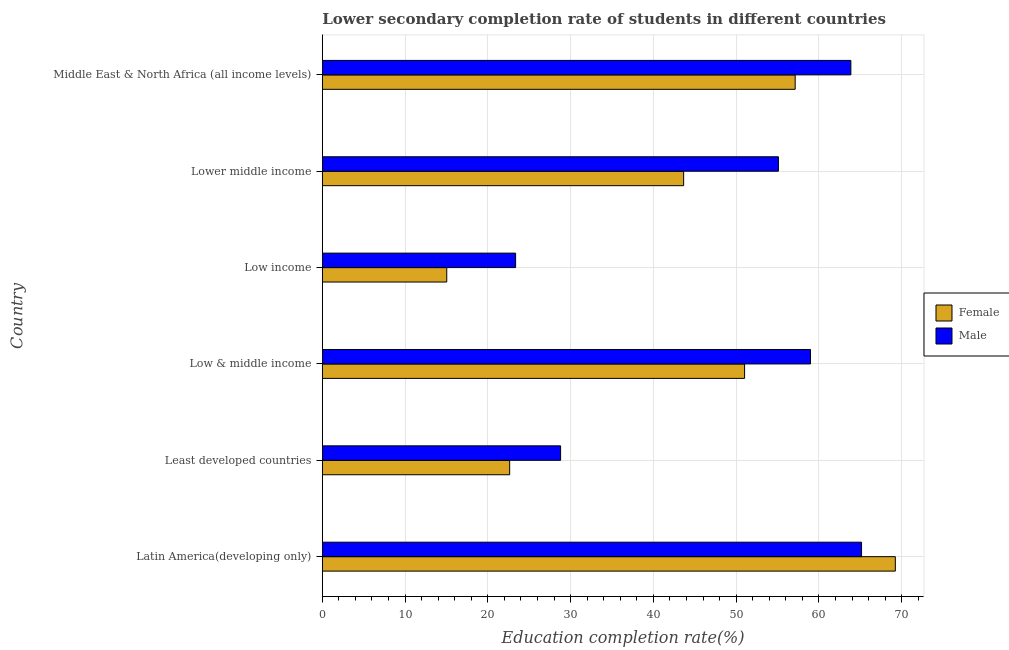How many different coloured bars are there?
Your response must be concise. 2. Are the number of bars per tick equal to the number of legend labels?
Make the answer very short. Yes. How many bars are there on the 1st tick from the bottom?
Make the answer very short. 2. What is the label of the 1st group of bars from the top?
Keep it short and to the point. Middle East & North Africa (all income levels). In how many cases, is the number of bars for a given country not equal to the number of legend labels?
Give a very brief answer. 0. What is the education completion rate of female students in Latin America(developing only)?
Keep it short and to the point. 69.23. Across all countries, what is the maximum education completion rate of female students?
Your answer should be compact. 69.23. Across all countries, what is the minimum education completion rate of female students?
Provide a short and direct response. 15.03. In which country was the education completion rate of female students maximum?
Keep it short and to the point. Latin America(developing only). In which country was the education completion rate of female students minimum?
Make the answer very short. Low income. What is the total education completion rate of female students in the graph?
Make the answer very short. 258.71. What is the difference between the education completion rate of male students in Least developed countries and that in Low income?
Make the answer very short. 5.43. What is the difference between the education completion rate of female students in Latin America(developing only) and the education completion rate of male students in Lower middle income?
Ensure brevity in your answer.  14.13. What is the average education completion rate of male students per country?
Your answer should be very brief. 49.21. What is the difference between the education completion rate of male students and education completion rate of female students in Low & middle income?
Make the answer very short. 7.97. What is the ratio of the education completion rate of female students in Least developed countries to that in Low & middle income?
Provide a succinct answer. 0.44. Is the education completion rate of male students in Latin America(developing only) less than that in Least developed countries?
Offer a very short reply. No. What is the difference between the highest and the second highest education completion rate of female students?
Offer a very short reply. 12.1. What is the difference between the highest and the lowest education completion rate of female students?
Your response must be concise. 54.2. What does the 2nd bar from the top in Middle East & North Africa (all income levels) represents?
Your response must be concise. Female. What does the 1st bar from the bottom in Lower middle income represents?
Ensure brevity in your answer.  Female. How many bars are there?
Your response must be concise. 12. How many countries are there in the graph?
Provide a succinct answer. 6. What is the difference between two consecutive major ticks on the X-axis?
Your response must be concise. 10. Does the graph contain any zero values?
Provide a succinct answer. No. Where does the legend appear in the graph?
Make the answer very short. Center right. How are the legend labels stacked?
Your answer should be compact. Vertical. What is the title of the graph?
Ensure brevity in your answer.  Lower secondary completion rate of students in different countries. What is the label or title of the X-axis?
Give a very brief answer. Education completion rate(%). What is the label or title of the Y-axis?
Provide a succinct answer. Country. What is the Education completion rate(%) of Female in Latin America(developing only)?
Give a very brief answer. 69.23. What is the Education completion rate(%) in Male in Latin America(developing only)?
Your answer should be compact. 65.15. What is the Education completion rate(%) of Female in Least developed countries?
Ensure brevity in your answer.  22.63. What is the Education completion rate(%) in Male in Least developed countries?
Ensure brevity in your answer.  28.79. What is the Education completion rate(%) in Female in Low & middle income?
Provide a succinct answer. 51.02. What is the Education completion rate(%) of Male in Low & middle income?
Give a very brief answer. 58.98. What is the Education completion rate(%) of Female in Low income?
Keep it short and to the point. 15.03. What is the Education completion rate(%) of Male in Low income?
Offer a very short reply. 23.35. What is the Education completion rate(%) of Female in Lower middle income?
Give a very brief answer. 43.66. What is the Education completion rate(%) of Male in Lower middle income?
Your answer should be very brief. 55.11. What is the Education completion rate(%) of Female in Middle East & North Africa (all income levels)?
Your answer should be compact. 57.13. What is the Education completion rate(%) of Male in Middle East & North Africa (all income levels)?
Make the answer very short. 63.86. Across all countries, what is the maximum Education completion rate(%) in Female?
Your response must be concise. 69.23. Across all countries, what is the maximum Education completion rate(%) of Male?
Offer a very short reply. 65.15. Across all countries, what is the minimum Education completion rate(%) in Female?
Keep it short and to the point. 15.03. Across all countries, what is the minimum Education completion rate(%) of Male?
Offer a terse response. 23.35. What is the total Education completion rate(%) in Female in the graph?
Your answer should be very brief. 258.71. What is the total Education completion rate(%) in Male in the graph?
Provide a short and direct response. 295.24. What is the difference between the Education completion rate(%) of Female in Latin America(developing only) and that in Least developed countries?
Offer a very short reply. 46.6. What is the difference between the Education completion rate(%) of Male in Latin America(developing only) and that in Least developed countries?
Provide a succinct answer. 36.36. What is the difference between the Education completion rate(%) of Female in Latin America(developing only) and that in Low & middle income?
Keep it short and to the point. 18.21. What is the difference between the Education completion rate(%) in Male in Latin America(developing only) and that in Low & middle income?
Keep it short and to the point. 6.17. What is the difference between the Education completion rate(%) in Female in Latin America(developing only) and that in Low income?
Make the answer very short. 54.2. What is the difference between the Education completion rate(%) of Male in Latin America(developing only) and that in Low income?
Provide a short and direct response. 41.8. What is the difference between the Education completion rate(%) in Female in Latin America(developing only) and that in Lower middle income?
Ensure brevity in your answer.  25.58. What is the difference between the Education completion rate(%) of Male in Latin America(developing only) and that in Lower middle income?
Provide a short and direct response. 10.04. What is the difference between the Education completion rate(%) in Female in Latin America(developing only) and that in Middle East & North Africa (all income levels)?
Keep it short and to the point. 12.1. What is the difference between the Education completion rate(%) in Male in Latin America(developing only) and that in Middle East & North Africa (all income levels)?
Give a very brief answer. 1.29. What is the difference between the Education completion rate(%) of Female in Least developed countries and that in Low & middle income?
Make the answer very short. -28.38. What is the difference between the Education completion rate(%) of Male in Least developed countries and that in Low & middle income?
Ensure brevity in your answer.  -30.19. What is the difference between the Education completion rate(%) of Female in Least developed countries and that in Low income?
Give a very brief answer. 7.6. What is the difference between the Education completion rate(%) of Male in Least developed countries and that in Low income?
Provide a short and direct response. 5.44. What is the difference between the Education completion rate(%) in Female in Least developed countries and that in Lower middle income?
Provide a succinct answer. -21.02. What is the difference between the Education completion rate(%) of Male in Least developed countries and that in Lower middle income?
Ensure brevity in your answer.  -26.32. What is the difference between the Education completion rate(%) in Female in Least developed countries and that in Middle East & North Africa (all income levels)?
Make the answer very short. -34.5. What is the difference between the Education completion rate(%) of Male in Least developed countries and that in Middle East & North Africa (all income levels)?
Offer a terse response. -35.07. What is the difference between the Education completion rate(%) in Female in Low & middle income and that in Low income?
Give a very brief answer. 35.99. What is the difference between the Education completion rate(%) of Male in Low & middle income and that in Low income?
Your answer should be compact. 35.63. What is the difference between the Education completion rate(%) in Female in Low & middle income and that in Lower middle income?
Keep it short and to the point. 7.36. What is the difference between the Education completion rate(%) in Male in Low & middle income and that in Lower middle income?
Make the answer very short. 3.88. What is the difference between the Education completion rate(%) of Female in Low & middle income and that in Middle East & North Africa (all income levels)?
Keep it short and to the point. -6.11. What is the difference between the Education completion rate(%) of Male in Low & middle income and that in Middle East & North Africa (all income levels)?
Offer a very short reply. -4.88. What is the difference between the Education completion rate(%) in Female in Low income and that in Lower middle income?
Provide a short and direct response. -28.62. What is the difference between the Education completion rate(%) in Male in Low income and that in Lower middle income?
Your answer should be very brief. -31.75. What is the difference between the Education completion rate(%) in Female in Low income and that in Middle East & North Africa (all income levels)?
Your answer should be compact. -42.1. What is the difference between the Education completion rate(%) in Male in Low income and that in Middle East & North Africa (all income levels)?
Offer a very short reply. -40.51. What is the difference between the Education completion rate(%) of Female in Lower middle income and that in Middle East & North Africa (all income levels)?
Offer a very short reply. -13.47. What is the difference between the Education completion rate(%) in Male in Lower middle income and that in Middle East & North Africa (all income levels)?
Your answer should be very brief. -8.75. What is the difference between the Education completion rate(%) of Female in Latin America(developing only) and the Education completion rate(%) of Male in Least developed countries?
Your answer should be very brief. 40.44. What is the difference between the Education completion rate(%) of Female in Latin America(developing only) and the Education completion rate(%) of Male in Low & middle income?
Offer a terse response. 10.25. What is the difference between the Education completion rate(%) in Female in Latin America(developing only) and the Education completion rate(%) in Male in Low income?
Make the answer very short. 45.88. What is the difference between the Education completion rate(%) in Female in Latin America(developing only) and the Education completion rate(%) in Male in Lower middle income?
Ensure brevity in your answer.  14.13. What is the difference between the Education completion rate(%) in Female in Latin America(developing only) and the Education completion rate(%) in Male in Middle East & North Africa (all income levels)?
Offer a very short reply. 5.37. What is the difference between the Education completion rate(%) in Female in Least developed countries and the Education completion rate(%) in Male in Low & middle income?
Your answer should be compact. -36.35. What is the difference between the Education completion rate(%) in Female in Least developed countries and the Education completion rate(%) in Male in Low income?
Your answer should be very brief. -0.72. What is the difference between the Education completion rate(%) of Female in Least developed countries and the Education completion rate(%) of Male in Lower middle income?
Keep it short and to the point. -32.47. What is the difference between the Education completion rate(%) in Female in Least developed countries and the Education completion rate(%) in Male in Middle East & North Africa (all income levels)?
Provide a short and direct response. -41.22. What is the difference between the Education completion rate(%) of Female in Low & middle income and the Education completion rate(%) of Male in Low income?
Provide a short and direct response. 27.66. What is the difference between the Education completion rate(%) in Female in Low & middle income and the Education completion rate(%) in Male in Lower middle income?
Ensure brevity in your answer.  -4.09. What is the difference between the Education completion rate(%) in Female in Low & middle income and the Education completion rate(%) in Male in Middle East & North Africa (all income levels)?
Make the answer very short. -12.84. What is the difference between the Education completion rate(%) of Female in Low income and the Education completion rate(%) of Male in Lower middle income?
Your answer should be compact. -40.07. What is the difference between the Education completion rate(%) of Female in Low income and the Education completion rate(%) of Male in Middle East & North Africa (all income levels)?
Your answer should be very brief. -48.83. What is the difference between the Education completion rate(%) of Female in Lower middle income and the Education completion rate(%) of Male in Middle East & North Africa (all income levels)?
Offer a very short reply. -20.2. What is the average Education completion rate(%) of Female per country?
Your answer should be very brief. 43.12. What is the average Education completion rate(%) of Male per country?
Offer a very short reply. 49.21. What is the difference between the Education completion rate(%) of Female and Education completion rate(%) of Male in Latin America(developing only)?
Your answer should be compact. 4.08. What is the difference between the Education completion rate(%) in Female and Education completion rate(%) in Male in Least developed countries?
Offer a terse response. -6.15. What is the difference between the Education completion rate(%) in Female and Education completion rate(%) in Male in Low & middle income?
Give a very brief answer. -7.97. What is the difference between the Education completion rate(%) of Female and Education completion rate(%) of Male in Low income?
Offer a very short reply. -8.32. What is the difference between the Education completion rate(%) of Female and Education completion rate(%) of Male in Lower middle income?
Provide a short and direct response. -11.45. What is the difference between the Education completion rate(%) in Female and Education completion rate(%) in Male in Middle East & North Africa (all income levels)?
Ensure brevity in your answer.  -6.73. What is the ratio of the Education completion rate(%) in Female in Latin America(developing only) to that in Least developed countries?
Provide a succinct answer. 3.06. What is the ratio of the Education completion rate(%) in Male in Latin America(developing only) to that in Least developed countries?
Provide a succinct answer. 2.26. What is the ratio of the Education completion rate(%) in Female in Latin America(developing only) to that in Low & middle income?
Your response must be concise. 1.36. What is the ratio of the Education completion rate(%) of Male in Latin America(developing only) to that in Low & middle income?
Your answer should be compact. 1.1. What is the ratio of the Education completion rate(%) in Female in Latin America(developing only) to that in Low income?
Ensure brevity in your answer.  4.61. What is the ratio of the Education completion rate(%) in Male in Latin America(developing only) to that in Low income?
Offer a very short reply. 2.79. What is the ratio of the Education completion rate(%) in Female in Latin America(developing only) to that in Lower middle income?
Give a very brief answer. 1.59. What is the ratio of the Education completion rate(%) of Male in Latin America(developing only) to that in Lower middle income?
Provide a short and direct response. 1.18. What is the ratio of the Education completion rate(%) of Female in Latin America(developing only) to that in Middle East & North Africa (all income levels)?
Your response must be concise. 1.21. What is the ratio of the Education completion rate(%) in Male in Latin America(developing only) to that in Middle East & North Africa (all income levels)?
Provide a short and direct response. 1.02. What is the ratio of the Education completion rate(%) of Female in Least developed countries to that in Low & middle income?
Ensure brevity in your answer.  0.44. What is the ratio of the Education completion rate(%) in Male in Least developed countries to that in Low & middle income?
Provide a succinct answer. 0.49. What is the ratio of the Education completion rate(%) of Female in Least developed countries to that in Low income?
Your answer should be compact. 1.51. What is the ratio of the Education completion rate(%) of Male in Least developed countries to that in Low income?
Offer a very short reply. 1.23. What is the ratio of the Education completion rate(%) in Female in Least developed countries to that in Lower middle income?
Ensure brevity in your answer.  0.52. What is the ratio of the Education completion rate(%) of Male in Least developed countries to that in Lower middle income?
Ensure brevity in your answer.  0.52. What is the ratio of the Education completion rate(%) of Female in Least developed countries to that in Middle East & North Africa (all income levels)?
Your answer should be very brief. 0.4. What is the ratio of the Education completion rate(%) of Male in Least developed countries to that in Middle East & North Africa (all income levels)?
Your answer should be very brief. 0.45. What is the ratio of the Education completion rate(%) of Female in Low & middle income to that in Low income?
Keep it short and to the point. 3.39. What is the ratio of the Education completion rate(%) in Male in Low & middle income to that in Low income?
Give a very brief answer. 2.53. What is the ratio of the Education completion rate(%) of Female in Low & middle income to that in Lower middle income?
Give a very brief answer. 1.17. What is the ratio of the Education completion rate(%) of Male in Low & middle income to that in Lower middle income?
Ensure brevity in your answer.  1.07. What is the ratio of the Education completion rate(%) of Female in Low & middle income to that in Middle East & North Africa (all income levels)?
Offer a very short reply. 0.89. What is the ratio of the Education completion rate(%) of Male in Low & middle income to that in Middle East & North Africa (all income levels)?
Keep it short and to the point. 0.92. What is the ratio of the Education completion rate(%) in Female in Low income to that in Lower middle income?
Your response must be concise. 0.34. What is the ratio of the Education completion rate(%) of Male in Low income to that in Lower middle income?
Offer a very short reply. 0.42. What is the ratio of the Education completion rate(%) in Female in Low income to that in Middle East & North Africa (all income levels)?
Your response must be concise. 0.26. What is the ratio of the Education completion rate(%) of Male in Low income to that in Middle East & North Africa (all income levels)?
Your response must be concise. 0.37. What is the ratio of the Education completion rate(%) of Female in Lower middle income to that in Middle East & North Africa (all income levels)?
Offer a very short reply. 0.76. What is the ratio of the Education completion rate(%) in Male in Lower middle income to that in Middle East & North Africa (all income levels)?
Your response must be concise. 0.86. What is the difference between the highest and the second highest Education completion rate(%) in Female?
Provide a succinct answer. 12.1. What is the difference between the highest and the second highest Education completion rate(%) of Male?
Offer a very short reply. 1.29. What is the difference between the highest and the lowest Education completion rate(%) of Female?
Keep it short and to the point. 54.2. What is the difference between the highest and the lowest Education completion rate(%) of Male?
Your answer should be compact. 41.8. 